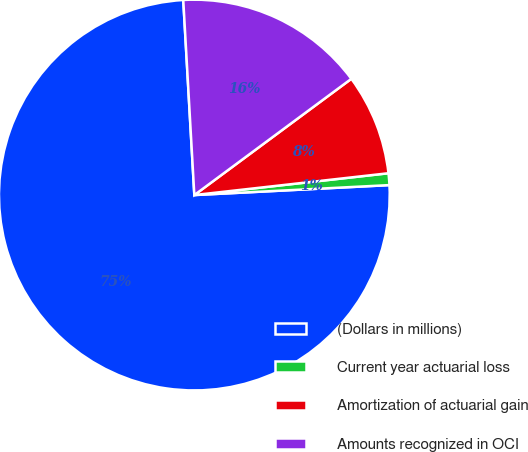Convert chart. <chart><loc_0><loc_0><loc_500><loc_500><pie_chart><fcel>(Dollars in millions)<fcel>Current year actuarial loss<fcel>Amortization of actuarial gain<fcel>Amounts recognized in OCI<nl><fcel>74.91%<fcel>0.97%<fcel>8.36%<fcel>15.76%<nl></chart> 